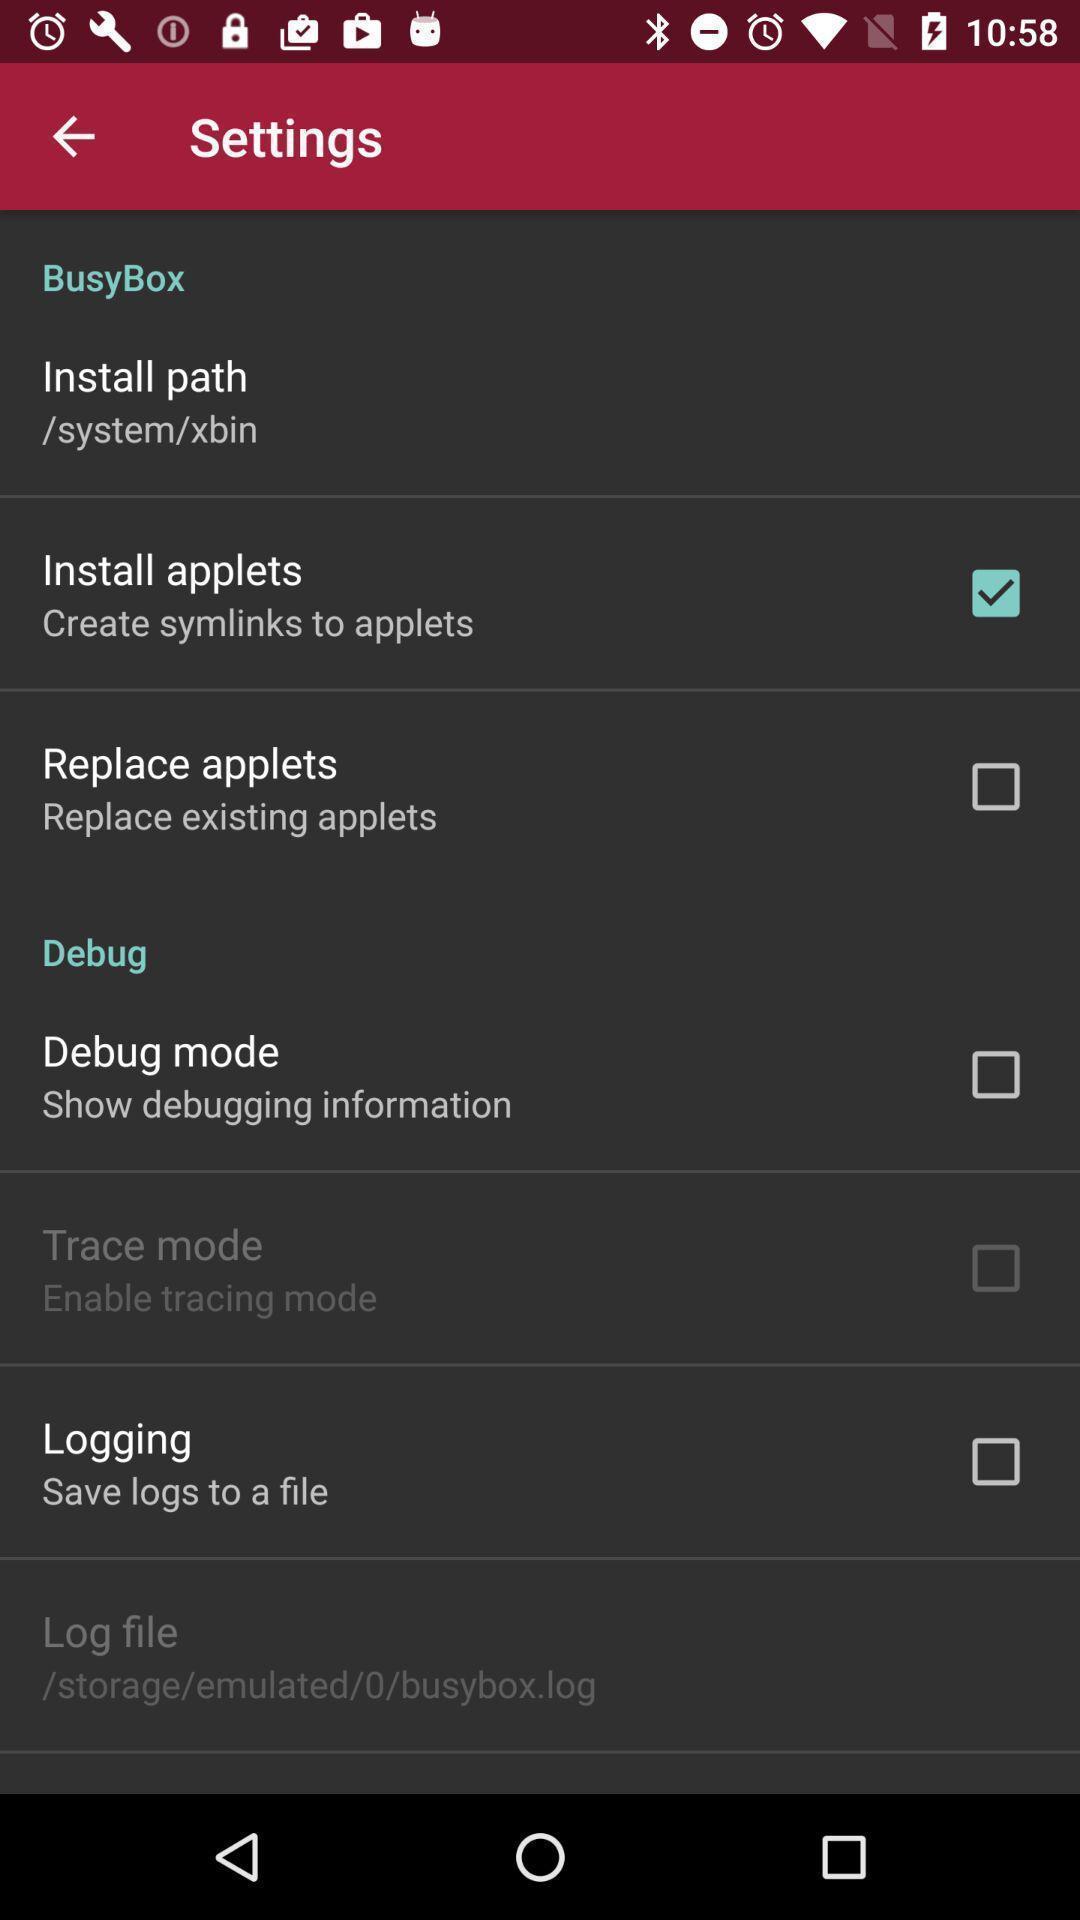Tell me about the visual elements in this screen capture. Settings page displayed. 